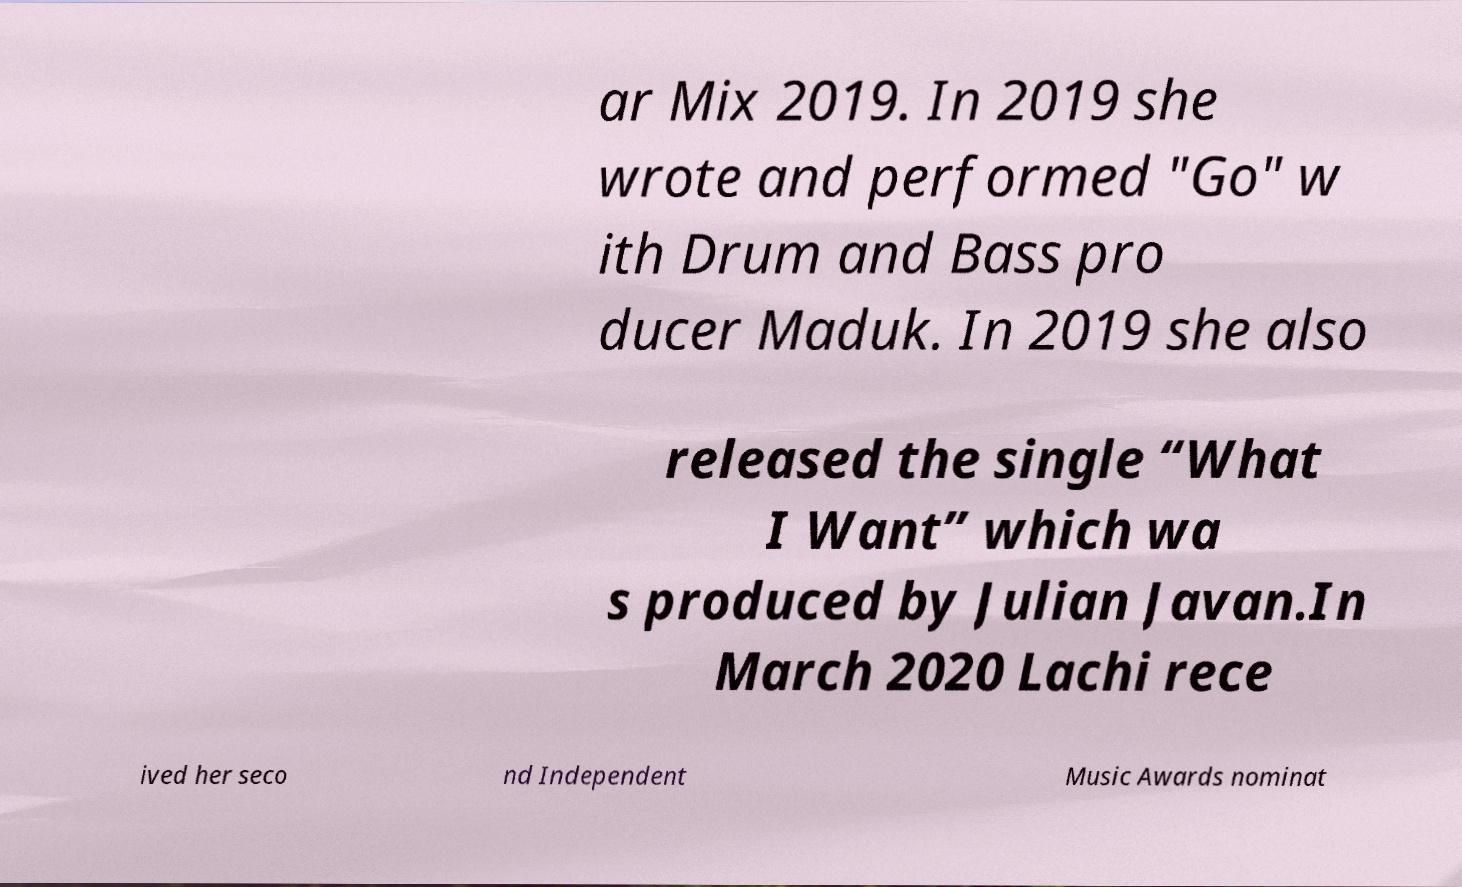Could you extract and type out the text from this image? ar Mix 2019. In 2019 she wrote and performed "Go" w ith Drum and Bass pro ducer Maduk. In 2019 she also released the single “What I Want” which wa s produced by Julian Javan.In March 2020 Lachi rece ived her seco nd Independent Music Awards nominat 